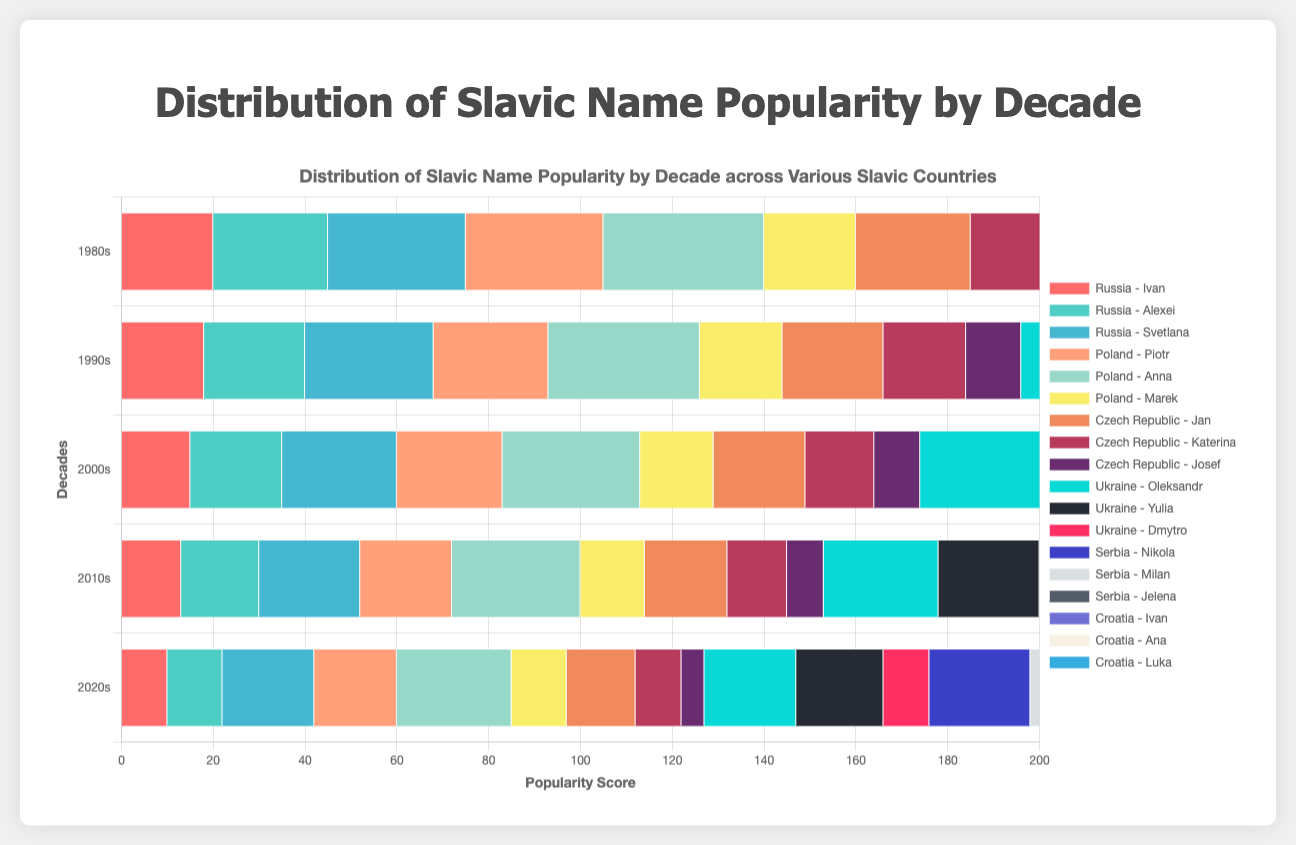Which name is the most popular in Croatia in the 2020s? According to the horizontal stacked bar chart, the first segment for Croatia in the 2020s reflects the popularity of "Ana" as it shows the highest bar length compared to other names.
Answer: Ana Which name had the highest popularity score in the 1980s across all countries? Looking at the length of the horizontal bars in the 1980s across all countries, "Oleksandr" in Ukraine has the longest bar.
Answer: Oleksandr Has the popularity of "Katerina" in the Czech Republic increased or decreased from the 1980s to the 2020s? The horizontal bar for "Katerina" in the 1980s is longer compared to the bar segment in the 2020s, indicating a decrease.
Answer: Decreased Compare the combined popularity scores for "Ivan" in Russia and Croatia across the 1980s and the 2020s. Which decade had a higher combined score? For Russia in the 1980s, "Ivan" has a score of 20, and in the 2020s, the score is 10. In Croatia, "Ivan" has 30 in the 1980s and 20 in the 2020s. Combined score for the 1980s = 20 + 30 = 50, and for the 2020s = 10 + 20 = 30. Hence, the 1980s had a higher combined score.
Answer: 1980s Which decade shows the highest popularity for "Anna" in Poland? The bar segment for "Anna" in Poland is longest in the 1980s compared to other decades.
Answer: 1980s How does the popularity of "Nikola" in Serbia in the 2000s compare to "Luka" in Croatia in the 2020s? "Nikola" in Serbia has a horizontal bar of 28 in the 2000s, whereas "Luka" in Croatia has a bar of 15 in the 2020s. Thus, "Nikola" has a higher score in the 2000s.
Answer: Nikola in the 2000s is more popular What is the average popularity score for "Svetlana" in Russia across the five decades? The popularity scores for "Svetlana" in Russia over the decades are (30, 28, 25, 22, 20). The average is calculated as (30 + 28 + 25 + 22 + 20) / 5 = 125 / 5 = 25.
Answer: 25 For which decade does "Piotr" in Poland have the lowest popularity score? By comparing the bar segments of "Piotr" in Poland, the 2020s have the shortest bar, indicating the lowest score.
Answer: 2020s Visually, which country has the most consistent popularity trends (least variation) for their listed names across decades? By observing the lengths of the horizontal bars, Serbia appears to have fairly consistent bar lengths for its names across decades with not much variation, particularly for "Nikola" and "Milan".
Answer: Serbia 